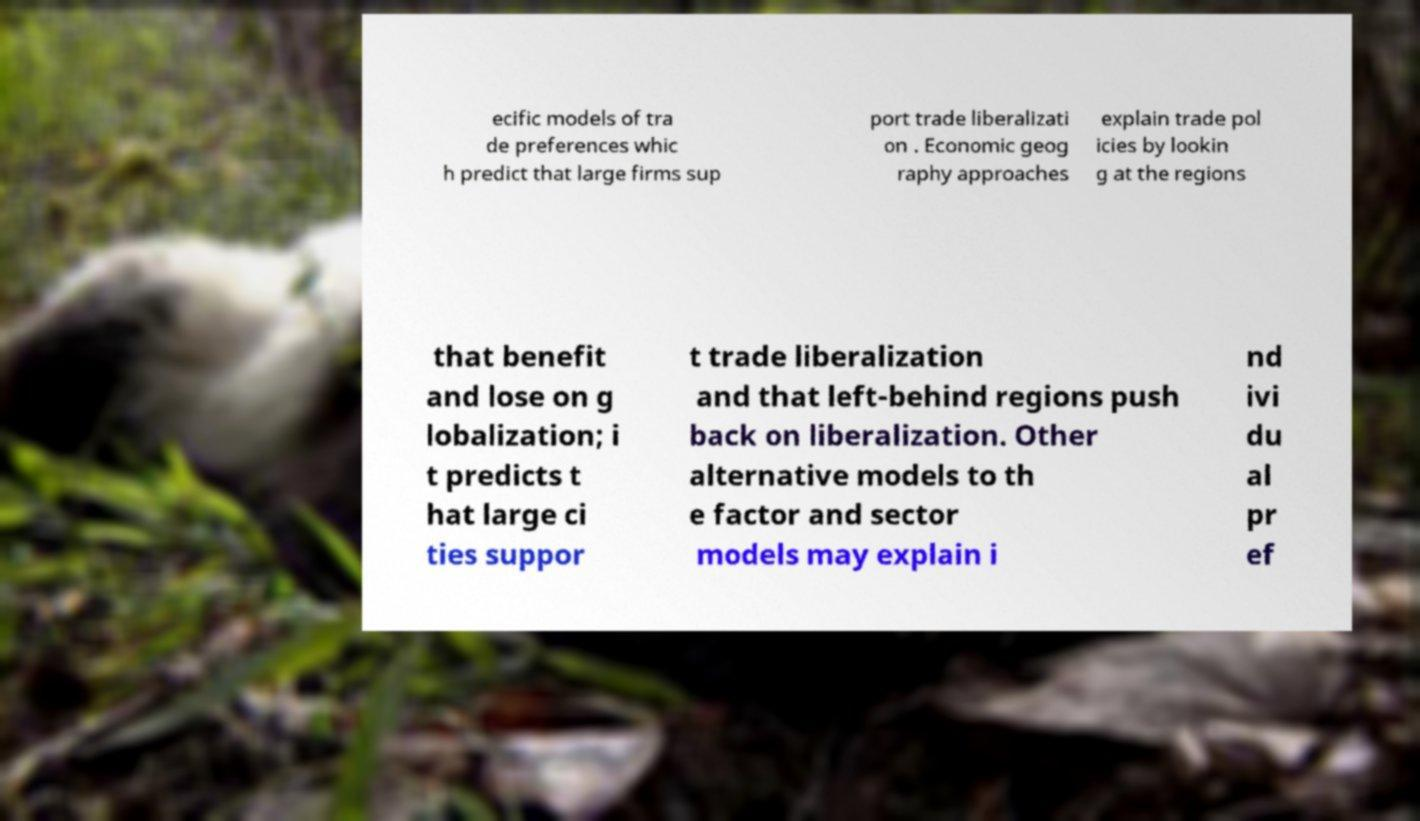What messages or text are displayed in this image? I need them in a readable, typed format. ecific models of tra de preferences whic h predict that large firms sup port trade liberalizati on . Economic geog raphy approaches explain trade pol icies by lookin g at the regions that benefit and lose on g lobalization; i t predicts t hat large ci ties suppor t trade liberalization and that left-behind regions push back on liberalization. Other alternative models to th e factor and sector models may explain i nd ivi du al pr ef 